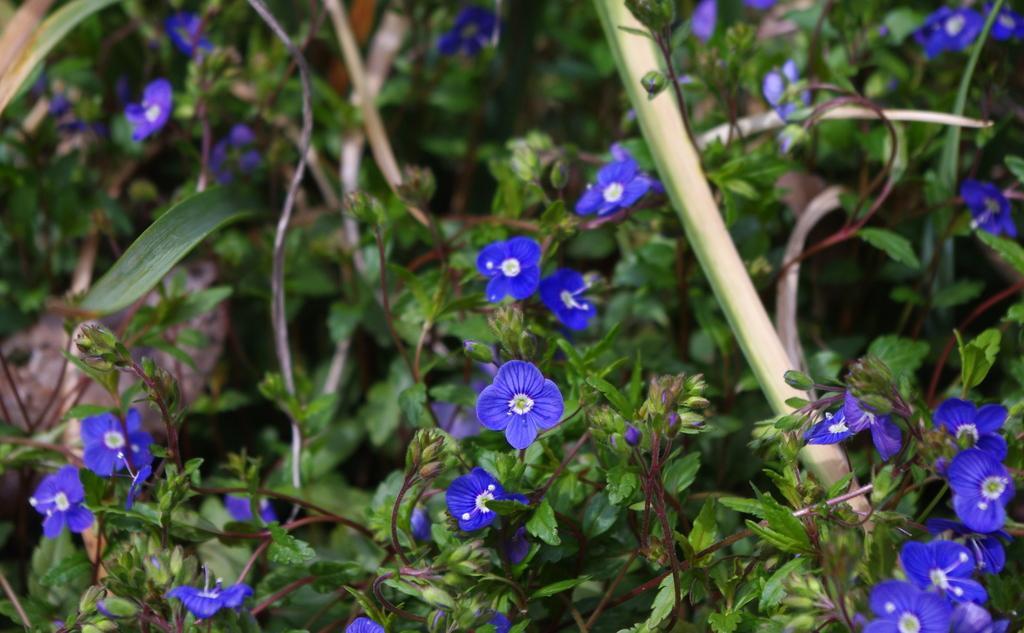In one or two sentences, can you explain what this image depicts? In this image there are many plants, flowers and leaves. 